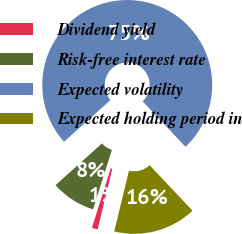Convert chart. <chart><loc_0><loc_0><loc_500><loc_500><pie_chart><fcel>Dividend yield<fcel>Risk-free interest rate<fcel>Expected volatility<fcel>Expected holding period in<nl><fcel>1.11%<fcel>8.46%<fcel>74.62%<fcel>15.81%<nl></chart> 